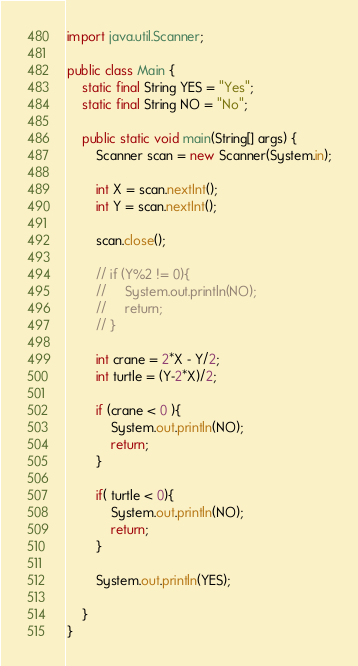<code> <loc_0><loc_0><loc_500><loc_500><_Java_>import java.util.Scanner;

public class Main {
    static final String YES = "Yes";
    static final String NO = "No";
    
    public static void main(String[] args) {
        Scanner scan = new Scanner(System.in);

        int X = scan.nextInt();
        int Y = scan.nextInt();

        scan.close();

        // if (Y%2 != 0){
        //     System.out.println(NO);
        //     return;
        // }

        int crane = 2*X - Y/2;
        int turtle = (Y-2*X)/2;

        if (crane < 0 ){
            System.out.println(NO);
            return;
        }

        if( turtle < 0){
            System.out.println(NO);
            return;
        }

        System.out.println(YES);
        
    }
}</code> 